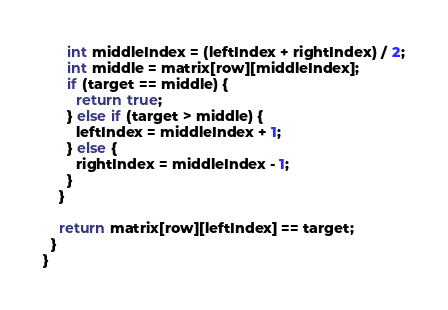Convert code to text. <code><loc_0><loc_0><loc_500><loc_500><_Java_>      int middleIndex = (leftIndex + rightIndex) / 2;
      int middle = matrix[row][middleIndex];
      if (target == middle) {
        return true;
      } else if (target > middle) {
        leftIndex = middleIndex + 1;
      } else {
        rightIndex = middleIndex - 1;
      }
    }

    return matrix[row][leftIndex] == target;
  }
}
</code> 